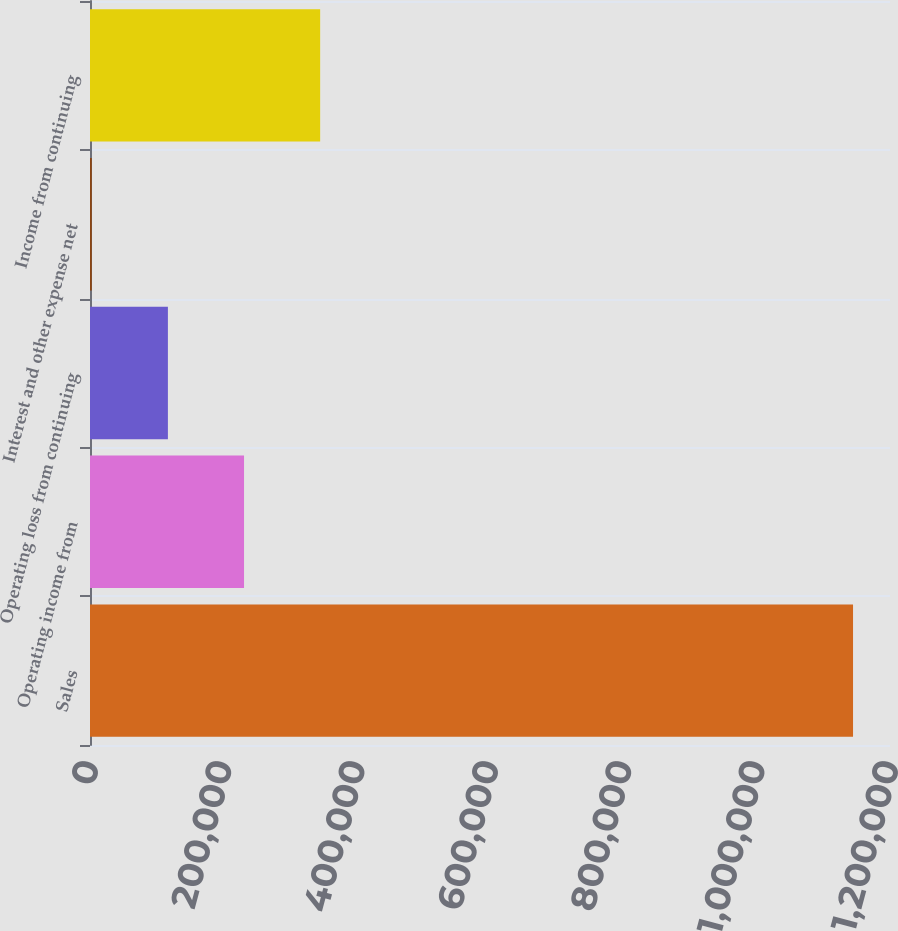Convert chart. <chart><loc_0><loc_0><loc_500><loc_500><bar_chart><fcel>Sales<fcel>Operating income from<fcel>Operating loss from continuing<fcel>Interest and other expense net<fcel>Income from continuing<nl><fcel>1.14456e+06<fcel>231045<fcel>116856<fcel>2666<fcel>345235<nl></chart> 